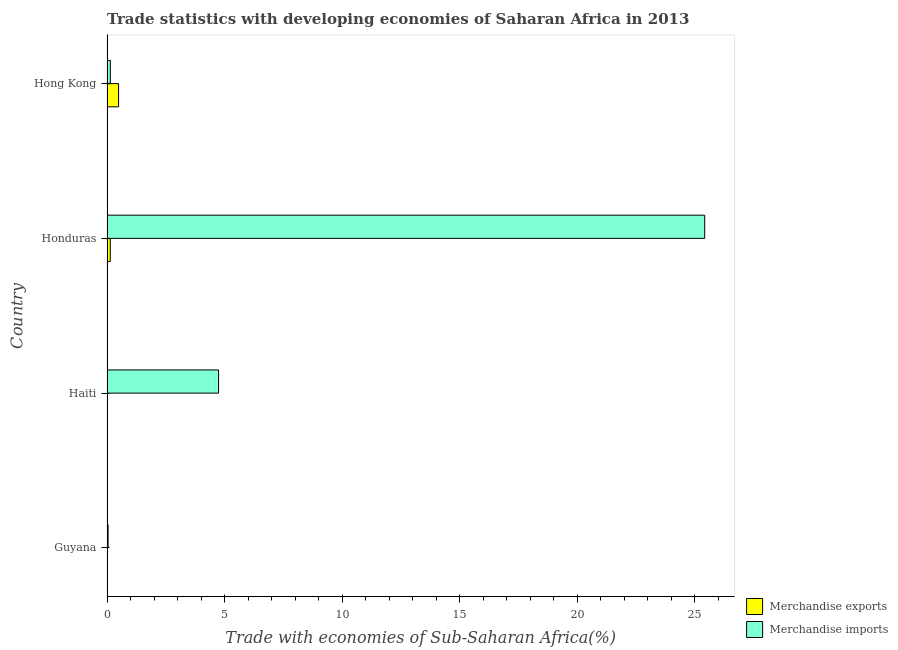Are the number of bars per tick equal to the number of legend labels?
Offer a very short reply. Yes. Are the number of bars on each tick of the Y-axis equal?
Offer a very short reply. Yes. How many bars are there on the 1st tick from the top?
Ensure brevity in your answer.  2. How many bars are there on the 3rd tick from the bottom?
Offer a very short reply. 2. What is the label of the 2nd group of bars from the top?
Keep it short and to the point. Honduras. In how many cases, is the number of bars for a given country not equal to the number of legend labels?
Give a very brief answer. 0. What is the merchandise exports in Guyana?
Offer a very short reply. 0.01. Across all countries, what is the maximum merchandise exports?
Offer a very short reply. 0.49. Across all countries, what is the minimum merchandise imports?
Make the answer very short. 0.05. In which country was the merchandise imports maximum?
Ensure brevity in your answer.  Honduras. In which country was the merchandise imports minimum?
Your answer should be very brief. Guyana. What is the total merchandise imports in the graph?
Your answer should be compact. 30.35. What is the difference between the merchandise imports in Guyana and that in Haiti?
Make the answer very short. -4.7. What is the difference between the merchandise exports in Guyana and the merchandise imports in Honduras?
Give a very brief answer. -25.4. What is the average merchandise exports per country?
Your response must be concise. 0.16. In how many countries, is the merchandise imports greater than 18 %?
Make the answer very short. 1. What is the ratio of the merchandise exports in Guyana to that in Hong Kong?
Your response must be concise. 0.02. Is the merchandise exports in Honduras less than that in Hong Kong?
Keep it short and to the point. Yes. Is the difference between the merchandise imports in Guyana and Hong Kong greater than the difference between the merchandise exports in Guyana and Hong Kong?
Your answer should be compact. Yes. What is the difference between the highest and the second highest merchandise exports?
Provide a succinct answer. 0.35. What is the difference between the highest and the lowest merchandise imports?
Provide a short and direct response. 25.37. Is the sum of the merchandise exports in Haiti and Hong Kong greater than the maximum merchandise imports across all countries?
Keep it short and to the point. No. What does the 2nd bar from the top in Haiti represents?
Your answer should be very brief. Merchandise exports. What does the 2nd bar from the bottom in Haiti represents?
Your answer should be very brief. Merchandise imports. How many bars are there?
Your answer should be very brief. 8. How many countries are there in the graph?
Provide a short and direct response. 4. Are the values on the major ticks of X-axis written in scientific E-notation?
Your response must be concise. No. Where does the legend appear in the graph?
Offer a very short reply. Bottom right. What is the title of the graph?
Your answer should be compact. Trade statistics with developing economies of Saharan Africa in 2013. What is the label or title of the X-axis?
Ensure brevity in your answer.  Trade with economies of Sub-Saharan Africa(%). What is the label or title of the Y-axis?
Your answer should be very brief. Country. What is the Trade with economies of Sub-Saharan Africa(%) of Merchandise exports in Guyana?
Provide a succinct answer. 0.01. What is the Trade with economies of Sub-Saharan Africa(%) of Merchandise imports in Guyana?
Make the answer very short. 0.05. What is the Trade with economies of Sub-Saharan Africa(%) of Merchandise exports in Haiti?
Give a very brief answer. 0.02. What is the Trade with economies of Sub-Saharan Africa(%) of Merchandise imports in Haiti?
Your answer should be compact. 4.74. What is the Trade with economies of Sub-Saharan Africa(%) in Merchandise exports in Honduras?
Keep it short and to the point. 0.14. What is the Trade with economies of Sub-Saharan Africa(%) in Merchandise imports in Honduras?
Ensure brevity in your answer.  25.41. What is the Trade with economies of Sub-Saharan Africa(%) in Merchandise exports in Hong Kong?
Give a very brief answer. 0.49. What is the Trade with economies of Sub-Saharan Africa(%) of Merchandise imports in Hong Kong?
Make the answer very short. 0.14. Across all countries, what is the maximum Trade with economies of Sub-Saharan Africa(%) of Merchandise exports?
Offer a terse response. 0.49. Across all countries, what is the maximum Trade with economies of Sub-Saharan Africa(%) in Merchandise imports?
Make the answer very short. 25.41. Across all countries, what is the minimum Trade with economies of Sub-Saharan Africa(%) in Merchandise exports?
Ensure brevity in your answer.  0.01. Across all countries, what is the minimum Trade with economies of Sub-Saharan Africa(%) in Merchandise imports?
Provide a succinct answer. 0.05. What is the total Trade with economies of Sub-Saharan Africa(%) of Merchandise exports in the graph?
Your answer should be very brief. 0.66. What is the total Trade with economies of Sub-Saharan Africa(%) in Merchandise imports in the graph?
Keep it short and to the point. 30.35. What is the difference between the Trade with economies of Sub-Saharan Africa(%) in Merchandise exports in Guyana and that in Haiti?
Your response must be concise. -0.01. What is the difference between the Trade with economies of Sub-Saharan Africa(%) in Merchandise imports in Guyana and that in Haiti?
Your response must be concise. -4.7. What is the difference between the Trade with economies of Sub-Saharan Africa(%) in Merchandise exports in Guyana and that in Honduras?
Your answer should be very brief. -0.13. What is the difference between the Trade with economies of Sub-Saharan Africa(%) in Merchandise imports in Guyana and that in Honduras?
Offer a very short reply. -25.37. What is the difference between the Trade with economies of Sub-Saharan Africa(%) in Merchandise exports in Guyana and that in Hong Kong?
Ensure brevity in your answer.  -0.48. What is the difference between the Trade with economies of Sub-Saharan Africa(%) of Merchandise imports in Guyana and that in Hong Kong?
Keep it short and to the point. -0.1. What is the difference between the Trade with economies of Sub-Saharan Africa(%) in Merchandise exports in Haiti and that in Honduras?
Keep it short and to the point. -0.12. What is the difference between the Trade with economies of Sub-Saharan Africa(%) in Merchandise imports in Haiti and that in Honduras?
Keep it short and to the point. -20.67. What is the difference between the Trade with economies of Sub-Saharan Africa(%) in Merchandise exports in Haiti and that in Hong Kong?
Keep it short and to the point. -0.47. What is the difference between the Trade with economies of Sub-Saharan Africa(%) in Merchandise imports in Haiti and that in Hong Kong?
Provide a short and direct response. 4.6. What is the difference between the Trade with economies of Sub-Saharan Africa(%) in Merchandise exports in Honduras and that in Hong Kong?
Your answer should be compact. -0.35. What is the difference between the Trade with economies of Sub-Saharan Africa(%) in Merchandise imports in Honduras and that in Hong Kong?
Provide a short and direct response. 25.27. What is the difference between the Trade with economies of Sub-Saharan Africa(%) in Merchandise exports in Guyana and the Trade with economies of Sub-Saharan Africa(%) in Merchandise imports in Haiti?
Provide a short and direct response. -4.74. What is the difference between the Trade with economies of Sub-Saharan Africa(%) in Merchandise exports in Guyana and the Trade with economies of Sub-Saharan Africa(%) in Merchandise imports in Honduras?
Provide a succinct answer. -25.41. What is the difference between the Trade with economies of Sub-Saharan Africa(%) of Merchandise exports in Guyana and the Trade with economies of Sub-Saharan Africa(%) of Merchandise imports in Hong Kong?
Make the answer very short. -0.13. What is the difference between the Trade with economies of Sub-Saharan Africa(%) of Merchandise exports in Haiti and the Trade with economies of Sub-Saharan Africa(%) of Merchandise imports in Honduras?
Offer a terse response. -25.39. What is the difference between the Trade with economies of Sub-Saharan Africa(%) of Merchandise exports in Haiti and the Trade with economies of Sub-Saharan Africa(%) of Merchandise imports in Hong Kong?
Offer a terse response. -0.12. What is the difference between the Trade with economies of Sub-Saharan Africa(%) of Merchandise exports in Honduras and the Trade with economies of Sub-Saharan Africa(%) of Merchandise imports in Hong Kong?
Make the answer very short. -0. What is the average Trade with economies of Sub-Saharan Africa(%) in Merchandise exports per country?
Your response must be concise. 0.16. What is the average Trade with economies of Sub-Saharan Africa(%) in Merchandise imports per country?
Provide a succinct answer. 7.59. What is the difference between the Trade with economies of Sub-Saharan Africa(%) in Merchandise exports and Trade with economies of Sub-Saharan Africa(%) in Merchandise imports in Guyana?
Keep it short and to the point. -0.04. What is the difference between the Trade with economies of Sub-Saharan Africa(%) of Merchandise exports and Trade with economies of Sub-Saharan Africa(%) of Merchandise imports in Haiti?
Your response must be concise. -4.73. What is the difference between the Trade with economies of Sub-Saharan Africa(%) in Merchandise exports and Trade with economies of Sub-Saharan Africa(%) in Merchandise imports in Honduras?
Give a very brief answer. -25.27. What is the difference between the Trade with economies of Sub-Saharan Africa(%) in Merchandise exports and Trade with economies of Sub-Saharan Africa(%) in Merchandise imports in Hong Kong?
Your response must be concise. 0.35. What is the ratio of the Trade with economies of Sub-Saharan Africa(%) in Merchandise exports in Guyana to that in Haiti?
Your response must be concise. 0.45. What is the ratio of the Trade with economies of Sub-Saharan Africa(%) in Merchandise imports in Guyana to that in Haiti?
Give a very brief answer. 0.01. What is the ratio of the Trade with economies of Sub-Saharan Africa(%) in Merchandise exports in Guyana to that in Honduras?
Give a very brief answer. 0.06. What is the ratio of the Trade with economies of Sub-Saharan Africa(%) of Merchandise imports in Guyana to that in Honduras?
Provide a succinct answer. 0. What is the ratio of the Trade with economies of Sub-Saharan Africa(%) in Merchandise exports in Guyana to that in Hong Kong?
Offer a very short reply. 0.02. What is the ratio of the Trade with economies of Sub-Saharan Africa(%) of Merchandise imports in Guyana to that in Hong Kong?
Your response must be concise. 0.33. What is the ratio of the Trade with economies of Sub-Saharan Africa(%) in Merchandise exports in Haiti to that in Honduras?
Give a very brief answer. 0.13. What is the ratio of the Trade with economies of Sub-Saharan Africa(%) in Merchandise imports in Haiti to that in Honduras?
Ensure brevity in your answer.  0.19. What is the ratio of the Trade with economies of Sub-Saharan Africa(%) in Merchandise exports in Haiti to that in Hong Kong?
Offer a terse response. 0.04. What is the ratio of the Trade with economies of Sub-Saharan Africa(%) of Merchandise imports in Haiti to that in Hong Kong?
Offer a terse response. 33.46. What is the ratio of the Trade with economies of Sub-Saharan Africa(%) in Merchandise exports in Honduras to that in Hong Kong?
Provide a short and direct response. 0.28. What is the ratio of the Trade with economies of Sub-Saharan Africa(%) in Merchandise imports in Honduras to that in Hong Kong?
Your answer should be very brief. 179.26. What is the difference between the highest and the second highest Trade with economies of Sub-Saharan Africa(%) of Merchandise exports?
Give a very brief answer. 0.35. What is the difference between the highest and the second highest Trade with economies of Sub-Saharan Africa(%) in Merchandise imports?
Your response must be concise. 20.67. What is the difference between the highest and the lowest Trade with economies of Sub-Saharan Africa(%) of Merchandise exports?
Offer a terse response. 0.48. What is the difference between the highest and the lowest Trade with economies of Sub-Saharan Africa(%) in Merchandise imports?
Ensure brevity in your answer.  25.37. 